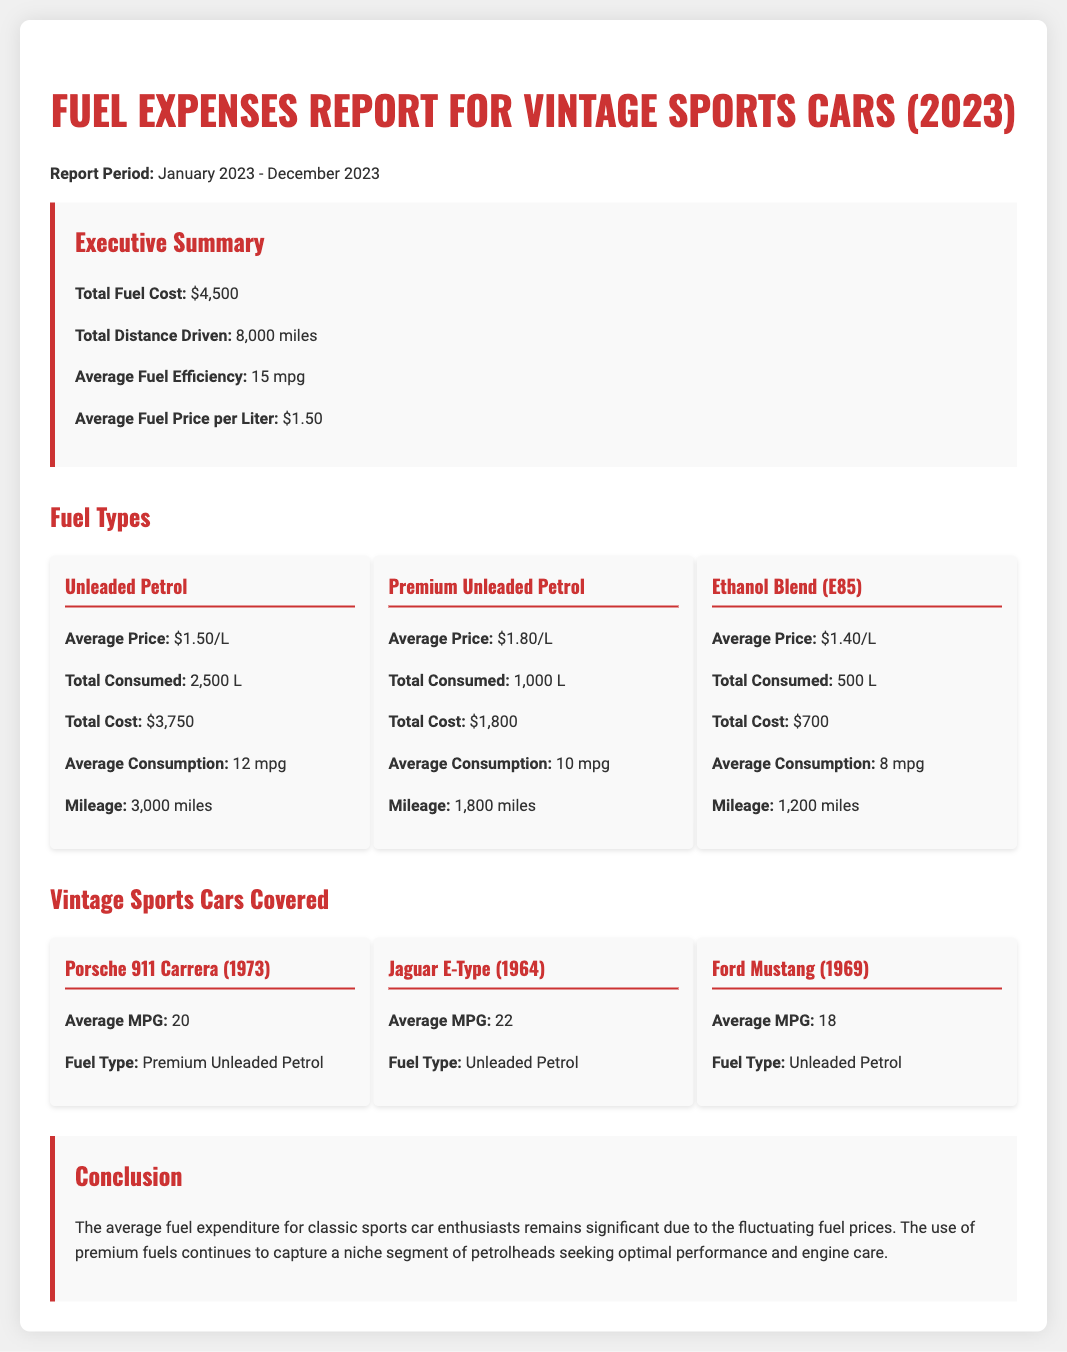what is the total fuel cost? The total fuel cost is provided in the summary section.
Answer: $4,500 what is the total distance driven? The total distance driven is reported in the executive summary.
Answer: 8,000 miles what is the average fuel efficiency? The average fuel efficiency is stated in the summary section of the report.
Answer: 15 mpg how much unleaded petrol was consumed? Total consumption of unleaded petrol is listed under fuel types.
Answer: 2,500 L what is the average price of premium unleaded petrol? The average price of premium unleaded petrol is mentioned in the fuel types section.
Answer: $1.80/L what mileage corresponds to ethanol blend (E85)? Mileage for ethanol blend is given in the fuel types section.
Answer: 1,200 miles which car type has the highest average MPG? The car with the highest average MPG is identified in the vintage sports cars section.
Answer: Jaguar E-Type (22 mpg) what is the total cost for ethanol blend (E85)? The total cost for ethanol blend is stated under the fuel types category.
Answer: $700 what is the primary purpose of this report? The conclusion summarizes the primary purpose of the report regarding fuel expenses for classic sports cars.
Answer: Fuel expenditure analysis 